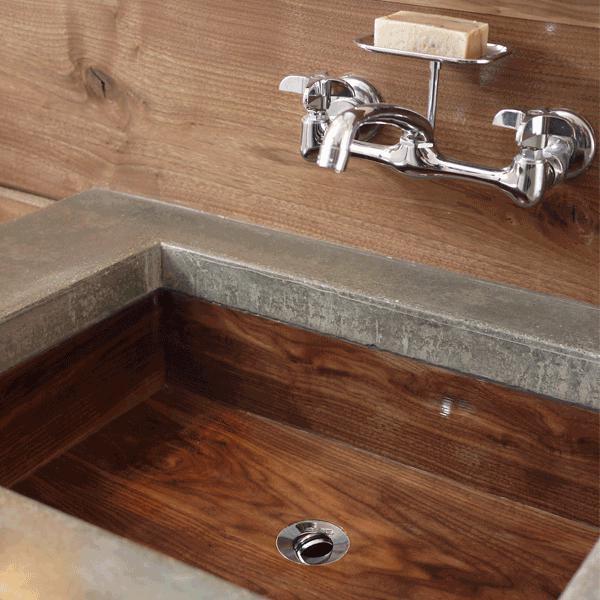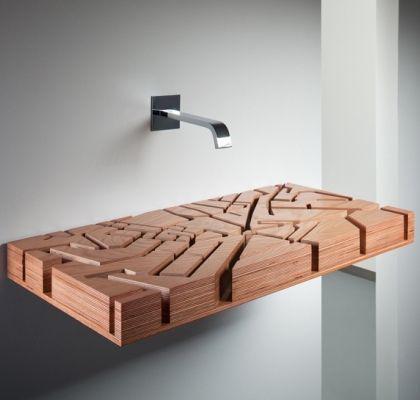The first image is the image on the left, the second image is the image on the right. Examine the images to the left and right. Is the description "An image shows a wall-mounted faucet and spout above a sink with a rectangular woodgrain basin." accurate? Answer yes or no. Yes. The first image is the image on the left, the second image is the image on the right. Considering the images on both sides, is "There are two sinks with faucets and bowls." valid? Answer yes or no. No. 